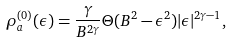<formula> <loc_0><loc_0><loc_500><loc_500>\rho ^ { ( 0 ) } _ { a } ( \epsilon ) = \frac { \gamma } { B ^ { 2 \gamma } } \Theta ( B ^ { 2 } - \epsilon ^ { 2 } ) | \epsilon | ^ { 2 \gamma - 1 } ,</formula> 